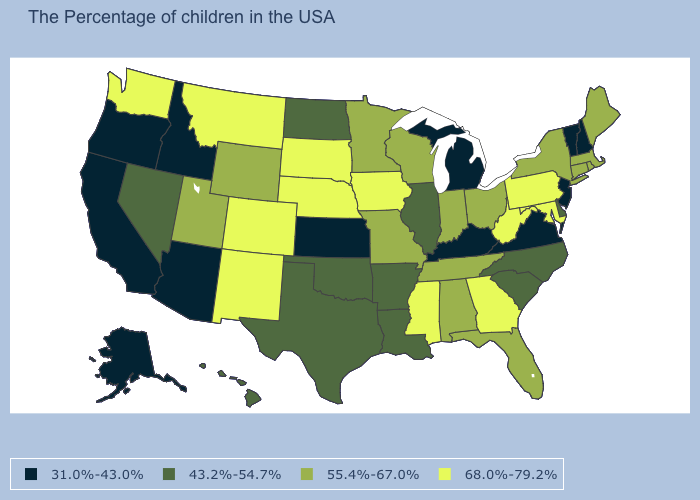How many symbols are there in the legend?
Be succinct. 4. Among the states that border Oregon , which have the highest value?
Write a very short answer. Washington. What is the value of South Carolina?
Concise answer only. 43.2%-54.7%. What is the value of North Carolina?
Quick response, please. 43.2%-54.7%. What is the value of Rhode Island?
Answer briefly. 55.4%-67.0%. Name the states that have a value in the range 68.0%-79.2%?
Give a very brief answer. Maryland, Pennsylvania, West Virginia, Georgia, Mississippi, Iowa, Nebraska, South Dakota, Colorado, New Mexico, Montana, Washington. Which states have the lowest value in the Northeast?
Be succinct. New Hampshire, Vermont, New Jersey. Name the states that have a value in the range 55.4%-67.0%?
Quick response, please. Maine, Massachusetts, Rhode Island, Connecticut, New York, Ohio, Florida, Indiana, Alabama, Tennessee, Wisconsin, Missouri, Minnesota, Wyoming, Utah. What is the value of Mississippi?
Write a very short answer. 68.0%-79.2%. What is the value of Colorado?
Quick response, please. 68.0%-79.2%. Among the states that border Arizona , does New Mexico have the highest value?
Short answer required. Yes. Which states have the highest value in the USA?
Answer briefly. Maryland, Pennsylvania, West Virginia, Georgia, Mississippi, Iowa, Nebraska, South Dakota, Colorado, New Mexico, Montana, Washington. Does Minnesota have the lowest value in the USA?
Concise answer only. No. Name the states that have a value in the range 43.2%-54.7%?
Answer briefly. Delaware, North Carolina, South Carolina, Illinois, Louisiana, Arkansas, Oklahoma, Texas, North Dakota, Nevada, Hawaii. 